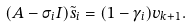<formula> <loc_0><loc_0><loc_500><loc_500>( A - \sigma _ { i } I ) \tilde { s } _ { i } = ( 1 - \gamma _ { i } ) v _ { k + 1 } .</formula> 